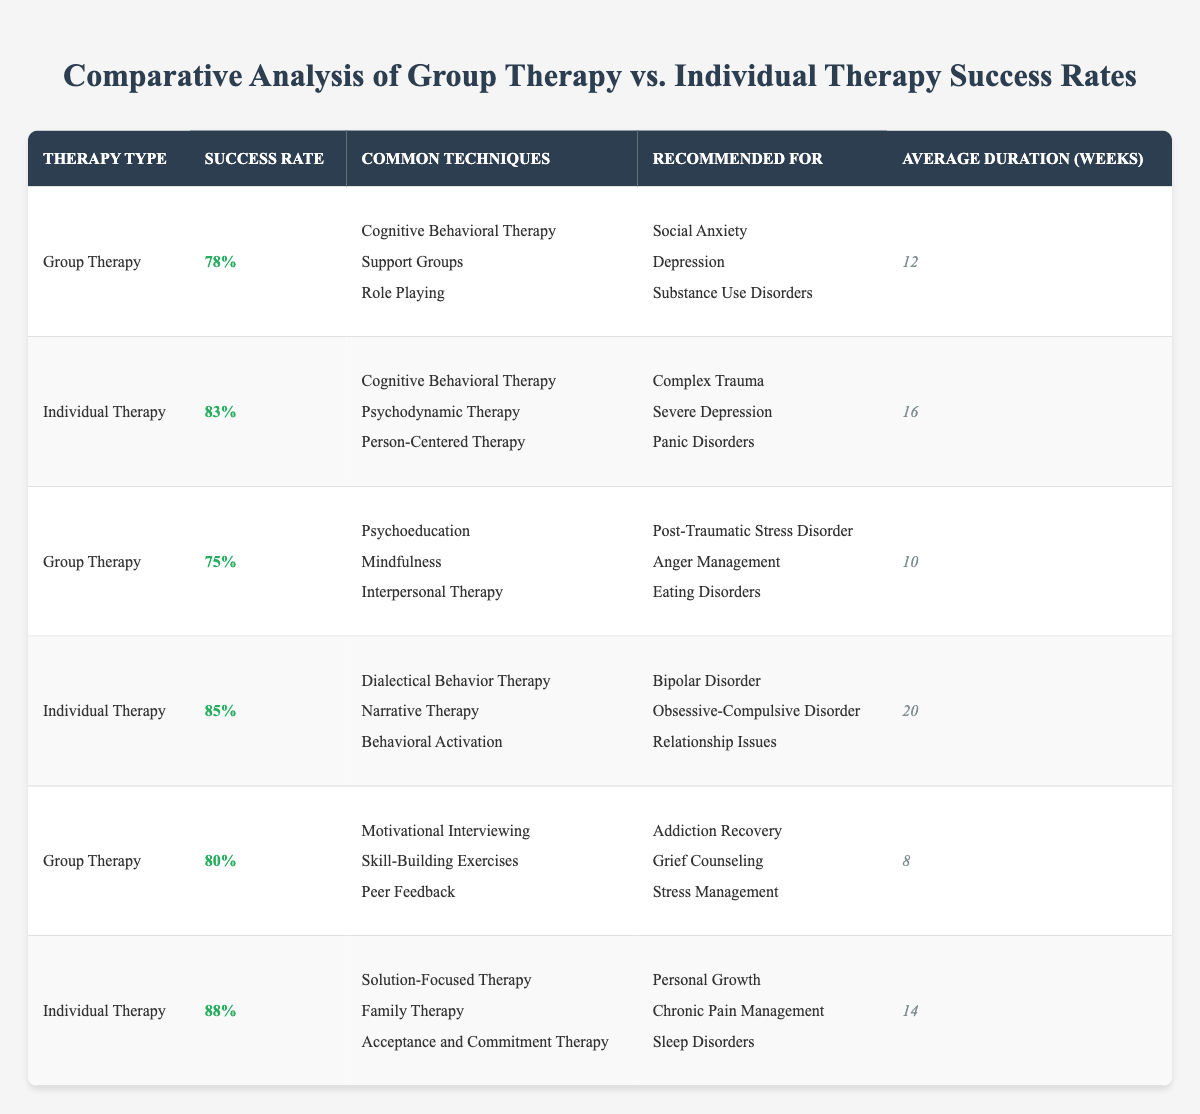What is the success rate of Group Therapy? According to the table, the success rates for Group Therapy are listed as 78%, 75%, and 80%. Therefore, the success rate of Group Therapy varies in the entries but is explicitly noted.
Answer: 78%, 75%, 80% What is the average duration of Individual Therapy? The average durations for Individual Therapy are 16 weeks, 20 weeks, and 14 weeks. To find the average: (16 + 20 + 14) / 3 = 50 / 3 = 16.67 weeks.
Answer: 16.67 weeks Is Dialectical Behavior Therapy listed as a common technique in Group Therapy? No, Dialectical Behavior Therapy is not mentioned among the common techniques for Group Therapy in the table. It is listed under Individual Therapy.
Answer: No Which therapy type has a higher average success rate, and what are the rates? The average success rates calculated are: Group Therapy: (78% + 75% + 80%) / 3 = 77.67%, Individual Therapy: (83% + 85% + 88%) / 3 = 85.33%. Thus, Individual Therapy has a higher average success rate of 85.33% compared to Group Therapy's 77.67%.
Answer: Individual Therapy, 85.33% What is the recommended therapy type for Anger Management? From the table, Group Therapy is recommended for Anger Management.
Answer: Group Therapy How many common techniques are listed for Group Therapy? Group Therapy showcases three distinct techniques in each of its entries; thus, there are three techniques listed for every instance of Group Therapy.
Answer: 3 What is the highest success rate recorded for Individual Therapy? By reviewing the Individual Therapy entries, the maximum recorded success rate is 88% in the last entry.
Answer: 88% Which therapy type is generally recommended for those experiencing Severe Depression? The table indicates that Severe Depression is recommended for Individual Therapy, as per the first relevant entry related to this condition.
Answer: Individual Therapy What is the range of average duration for the therapies? The durations for Group Therapy range from 8 to 12 weeks, while Individual Therapy ranges from 14 to 20 weeks. The overall range considering both therapies is 8 weeks to 20 weeks.
Answer: 8 to 20 weeks Which common technique is used in both Group Therapy and Individual Therapy? Cognitive Behavioral Therapy is mentioned as a common technique used in both Group Therapy and Individual Therapy entries.
Answer: Cognitive Behavioral Therapy How many weeks longer is the average duration of Individual Therapy compared to Group Therapy? Average duration of Individual Therapy is 16.67 weeks, while Group Therapy averages at 12.67 weeks. The difference is therefore 16.67 - 12.67 = 4 weeks longer.
Answer: 4 weeks 